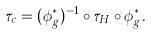<formula> <loc_0><loc_0><loc_500><loc_500>\tau _ { c } = ( \phi _ { g } ^ { * } ) ^ { - 1 } \circ \tau _ { H } \circ \phi _ { g } ^ { * } .</formula> 